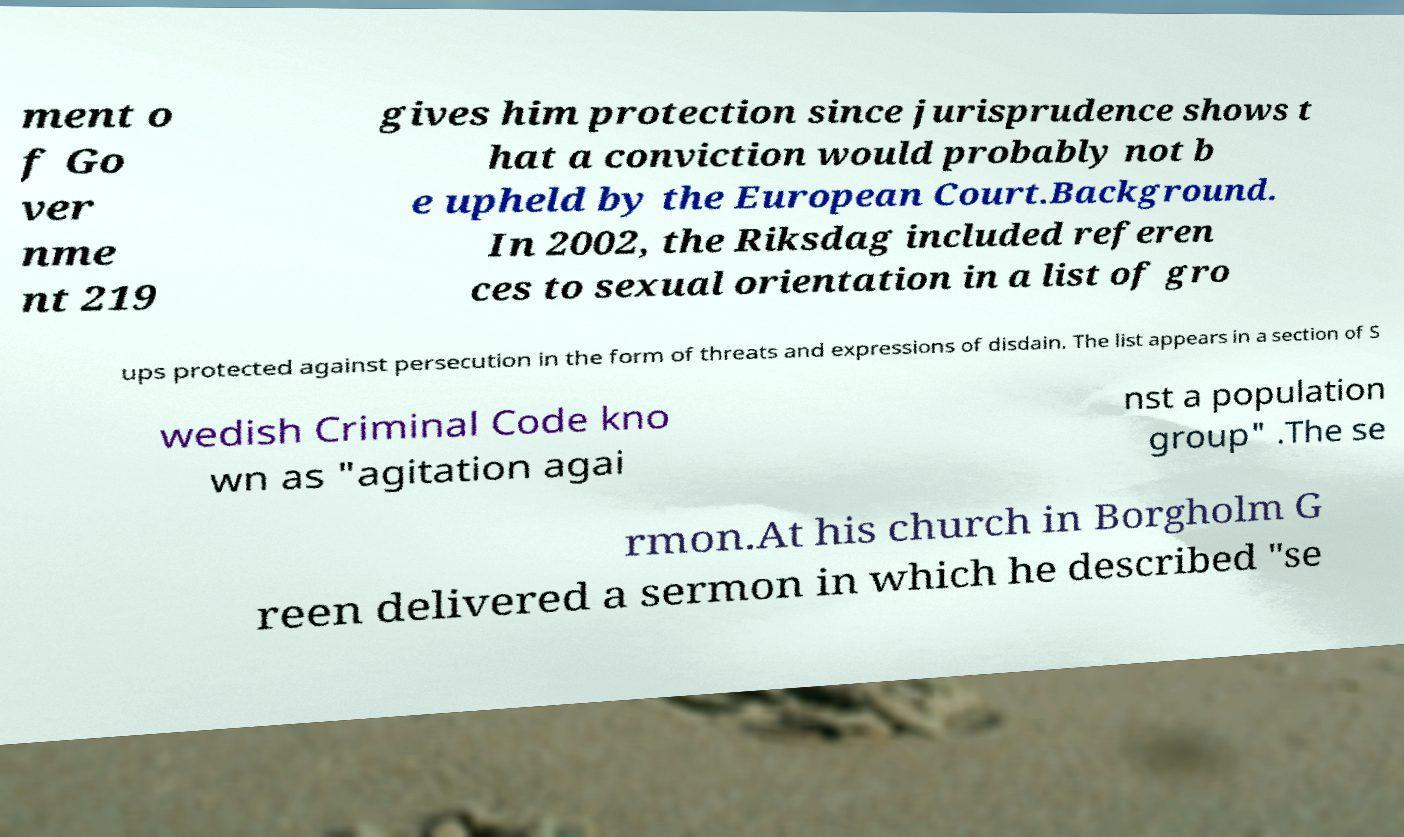Can you read and provide the text displayed in the image?This photo seems to have some interesting text. Can you extract and type it out for me? ment o f Go ver nme nt 219 gives him protection since jurisprudence shows t hat a conviction would probably not b e upheld by the European Court.Background. In 2002, the Riksdag included referen ces to sexual orientation in a list of gro ups protected against persecution in the form of threats and expressions of disdain. The list appears in a section of S wedish Criminal Code kno wn as "agitation agai nst a population group" .The se rmon.At his church in Borgholm G reen delivered a sermon in which he described "se 